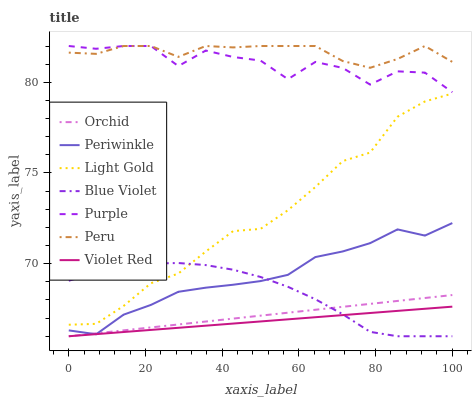Does Violet Red have the minimum area under the curve?
Answer yes or no. Yes. Does Peru have the maximum area under the curve?
Answer yes or no. Yes. Does Purple have the minimum area under the curve?
Answer yes or no. No. Does Purple have the maximum area under the curve?
Answer yes or no. No. Is Orchid the smoothest?
Answer yes or no. Yes. Is Purple the roughest?
Answer yes or no. Yes. Is Periwinkle the smoothest?
Answer yes or no. No. Is Periwinkle the roughest?
Answer yes or no. No. Does Violet Red have the lowest value?
Answer yes or no. Yes. Does Purple have the lowest value?
Answer yes or no. No. Does Peru have the highest value?
Answer yes or no. Yes. Does Periwinkle have the highest value?
Answer yes or no. No. Is Violet Red less than Peru?
Answer yes or no. Yes. Is Purple greater than Orchid?
Answer yes or no. Yes. Does Orchid intersect Violet Red?
Answer yes or no. Yes. Is Orchid less than Violet Red?
Answer yes or no. No. Is Orchid greater than Violet Red?
Answer yes or no. No. Does Violet Red intersect Peru?
Answer yes or no. No. 